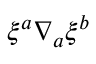Convert formula to latex. <formula><loc_0><loc_0><loc_500><loc_500>{ \xi } ^ { a } { \nabla } _ { a } { \xi } ^ { b }</formula> 